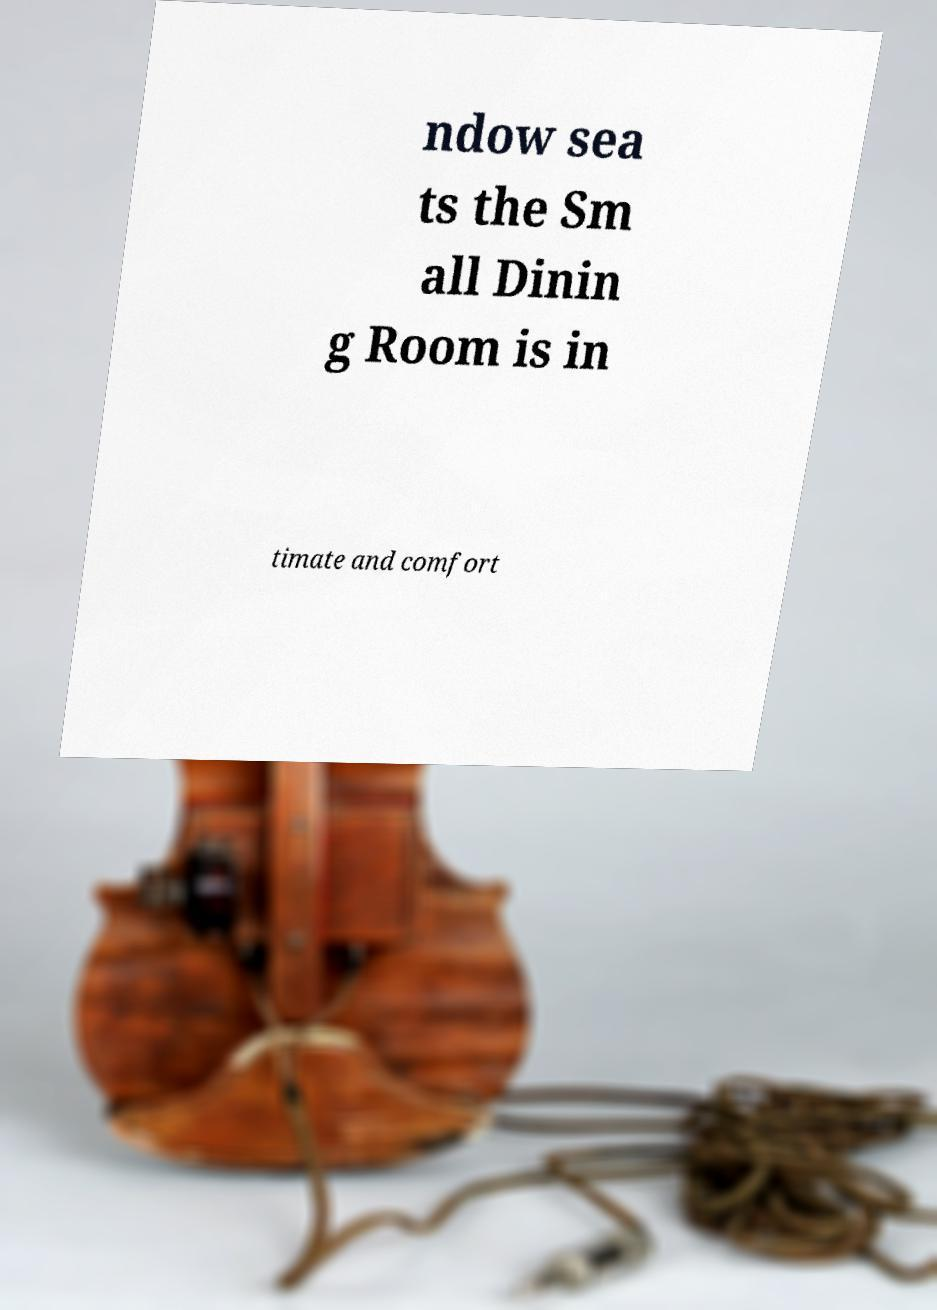I need the written content from this picture converted into text. Can you do that? ndow sea ts the Sm all Dinin g Room is in timate and comfort 